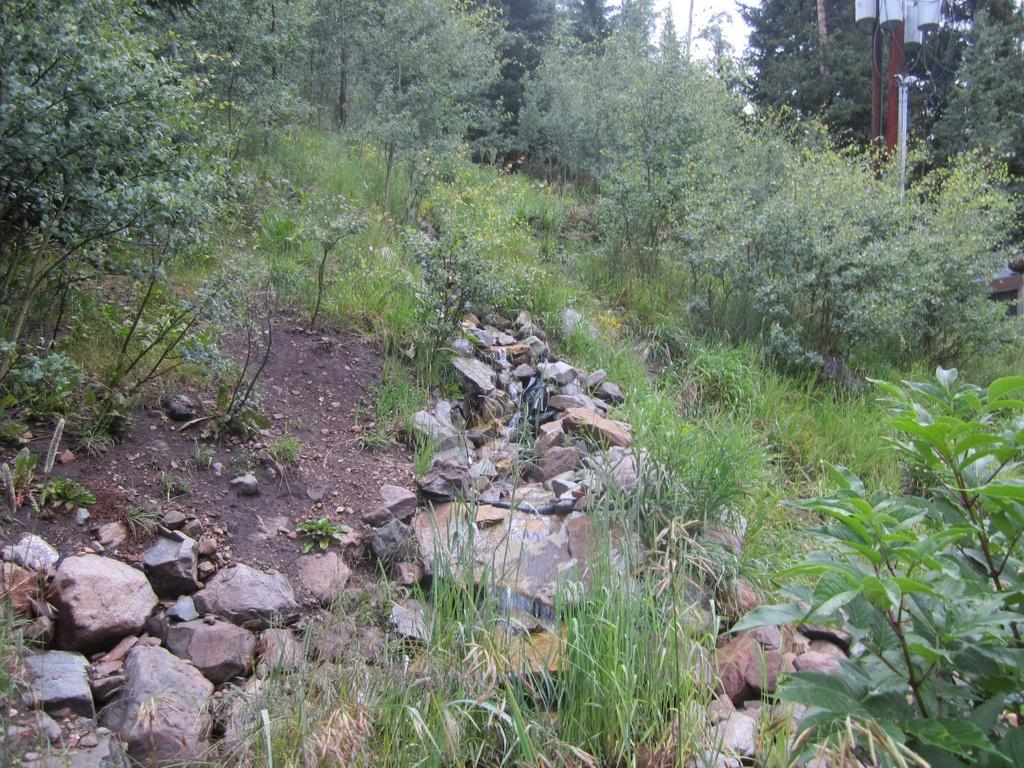What type of natural elements can be seen in the image? There are rocks, trees, and plants visible in the image. Can you describe the arrangement of the rocks in the image? The rocks are surrounded by many trees in the image. What is present in the background of the image? There is a pole and a white sky visible in the background of the image. Reasoning: Let's think step by step by step in order to produce the conversation. We start by identifying the main natural elements in the image, which are the rocks, trees, and plants. Then, we describe the arrangement of the rocks in relation to the trees. Finally, we mention the additional elements present in the background, which are the pole and the white sky. Each question is designed to elicit a specific detail about the image that is known from the provided facts. Absurd Question/Answer: What type of pollution can be seen in the image? There is no pollution visible in the image; it features rocks, trees, plants, a pole, and a white sky. Is there a field of beef in the image? There is no mention of beef or a field in the image; it contains rocks, trees, plants, a pole, and a white sky. What type of pollution can be seen in the image? There is no pollution visible in the image; it features rocks, trees, plants, a pole, and a white sky. Is there a field of beef in the image? There is no mention of beef or a field in the image; it contains rocks, trees, plants, a pole, and a white sky. 